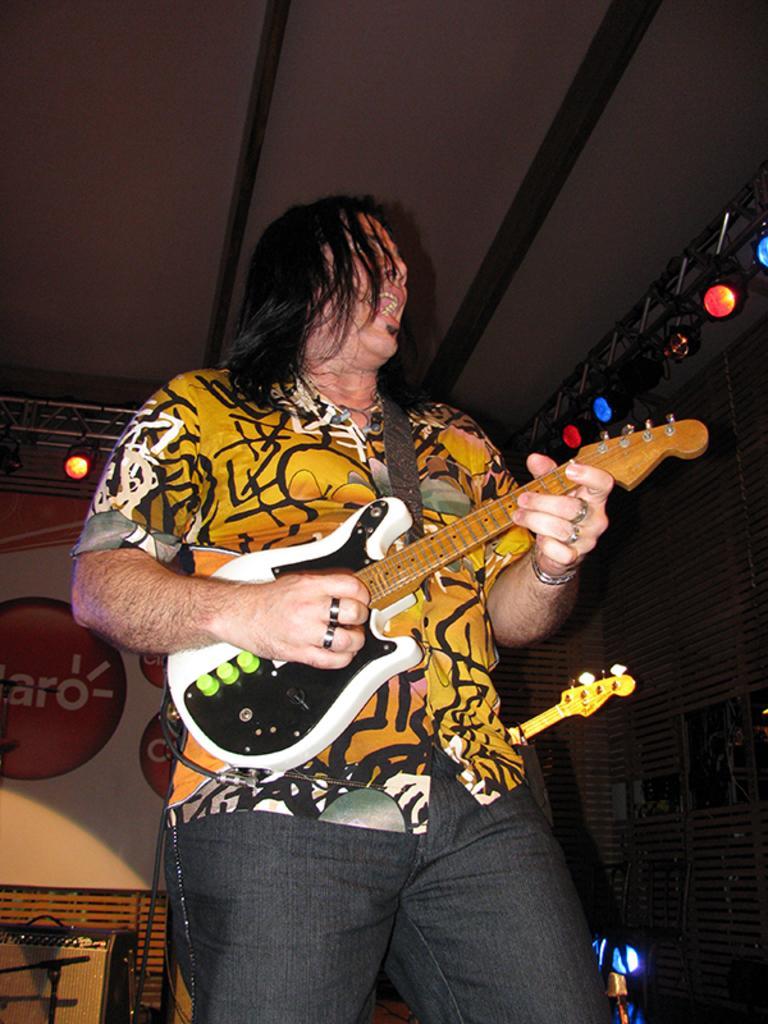Please provide a concise description of this image. In this picture I can see a man playing the guitar and also singing. On the right side there are lights, in the background it looks like a painting on the wall. 